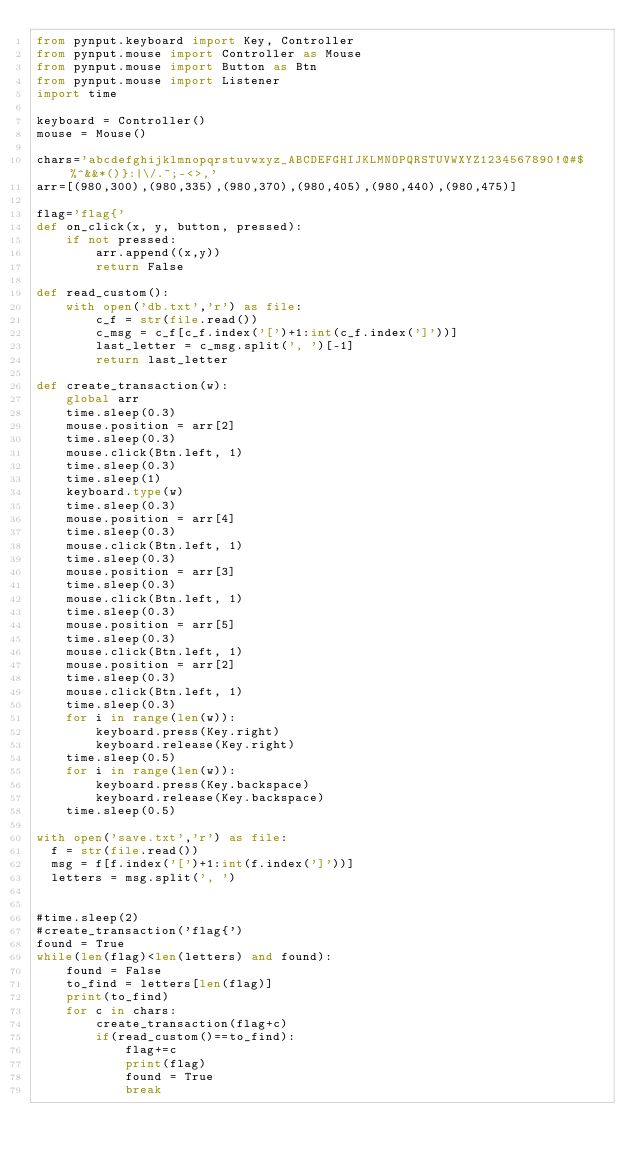Convert code to text. <code><loc_0><loc_0><loc_500><loc_500><_Python_>from pynput.keyboard import Key, Controller
from pynput.mouse import Controller as Mouse
from pynput.mouse import Button as Btn
from pynput.mouse import Listener
import time

keyboard = Controller()
mouse = Mouse()

chars='abcdefghijklmnopqrstuvwxyz_ABCDEFGHIJKLMNOPQRSTUVWXYZ1234567890!@#$%^&&*()}:|\/.~;-<>,'
arr=[(980,300),(980,335),(980,370),(980,405),(980,440),(980,475)]

flag='flag{'
def on_click(x, y, button, pressed):
    if not pressed:
        arr.append((x,y))
        return False

def read_custom():
    with open('db.txt','r') as file:
        c_f = str(file.read())
        c_msg = c_f[c_f.index('[')+1:int(c_f.index(']'))]
        last_letter = c_msg.split(', ')[-1]
        return last_letter

def create_transaction(w):
    global arr
    time.sleep(0.3)
    mouse.position = arr[2]
    time.sleep(0.3)
    mouse.click(Btn.left, 1)
    time.sleep(0.3)
    time.sleep(1)
    keyboard.type(w)
    time.sleep(0.3)
    mouse.position = arr[4]
    time.sleep(0.3)
    mouse.click(Btn.left, 1)
    time.sleep(0.3)
    mouse.position = arr[3]
    time.sleep(0.3)
    mouse.click(Btn.left, 1)
    time.sleep(0.3)
    mouse.position = arr[5]
    time.sleep(0.3)
    mouse.click(Btn.left, 1)
    mouse.position = arr[2]
    time.sleep(0.3)
    mouse.click(Btn.left, 1)
    time.sleep(0.3)
    for i in range(len(w)):
        keyboard.press(Key.right)
        keyboard.release(Key.right)
    time.sleep(0.5)
    for i in range(len(w)):
        keyboard.press(Key.backspace)
        keyboard.release(Key.backspace)
    time.sleep(0.5)
    
with open('save.txt','r') as file:
	f = str(file.read())
	msg = f[f.index('[')+1:int(f.index(']'))]
	letters = msg.split(', ')

	
#time.sleep(2)
#create_transaction('flag{')
found = True
while(len(flag)<len(letters) and found):
    found = False
    to_find = letters[len(flag)]
    print(to_find)
    for c in chars:
        create_transaction(flag+c)
        if(read_custom()==to_find):
            flag+=c
            print(flag)
            found = True
            break
        
            

</code> 